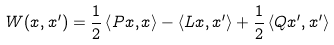<formula> <loc_0><loc_0><loc_500><loc_500>W ( x , x ^ { \prime } ) = \frac { 1 } { 2 } \left \langle P x , x \right \rangle - \left \langle L x , x ^ { \prime } \right \rangle + \frac { 1 } { 2 } \left \langle Q x ^ { \prime } , x ^ { \prime } \right \rangle</formula> 